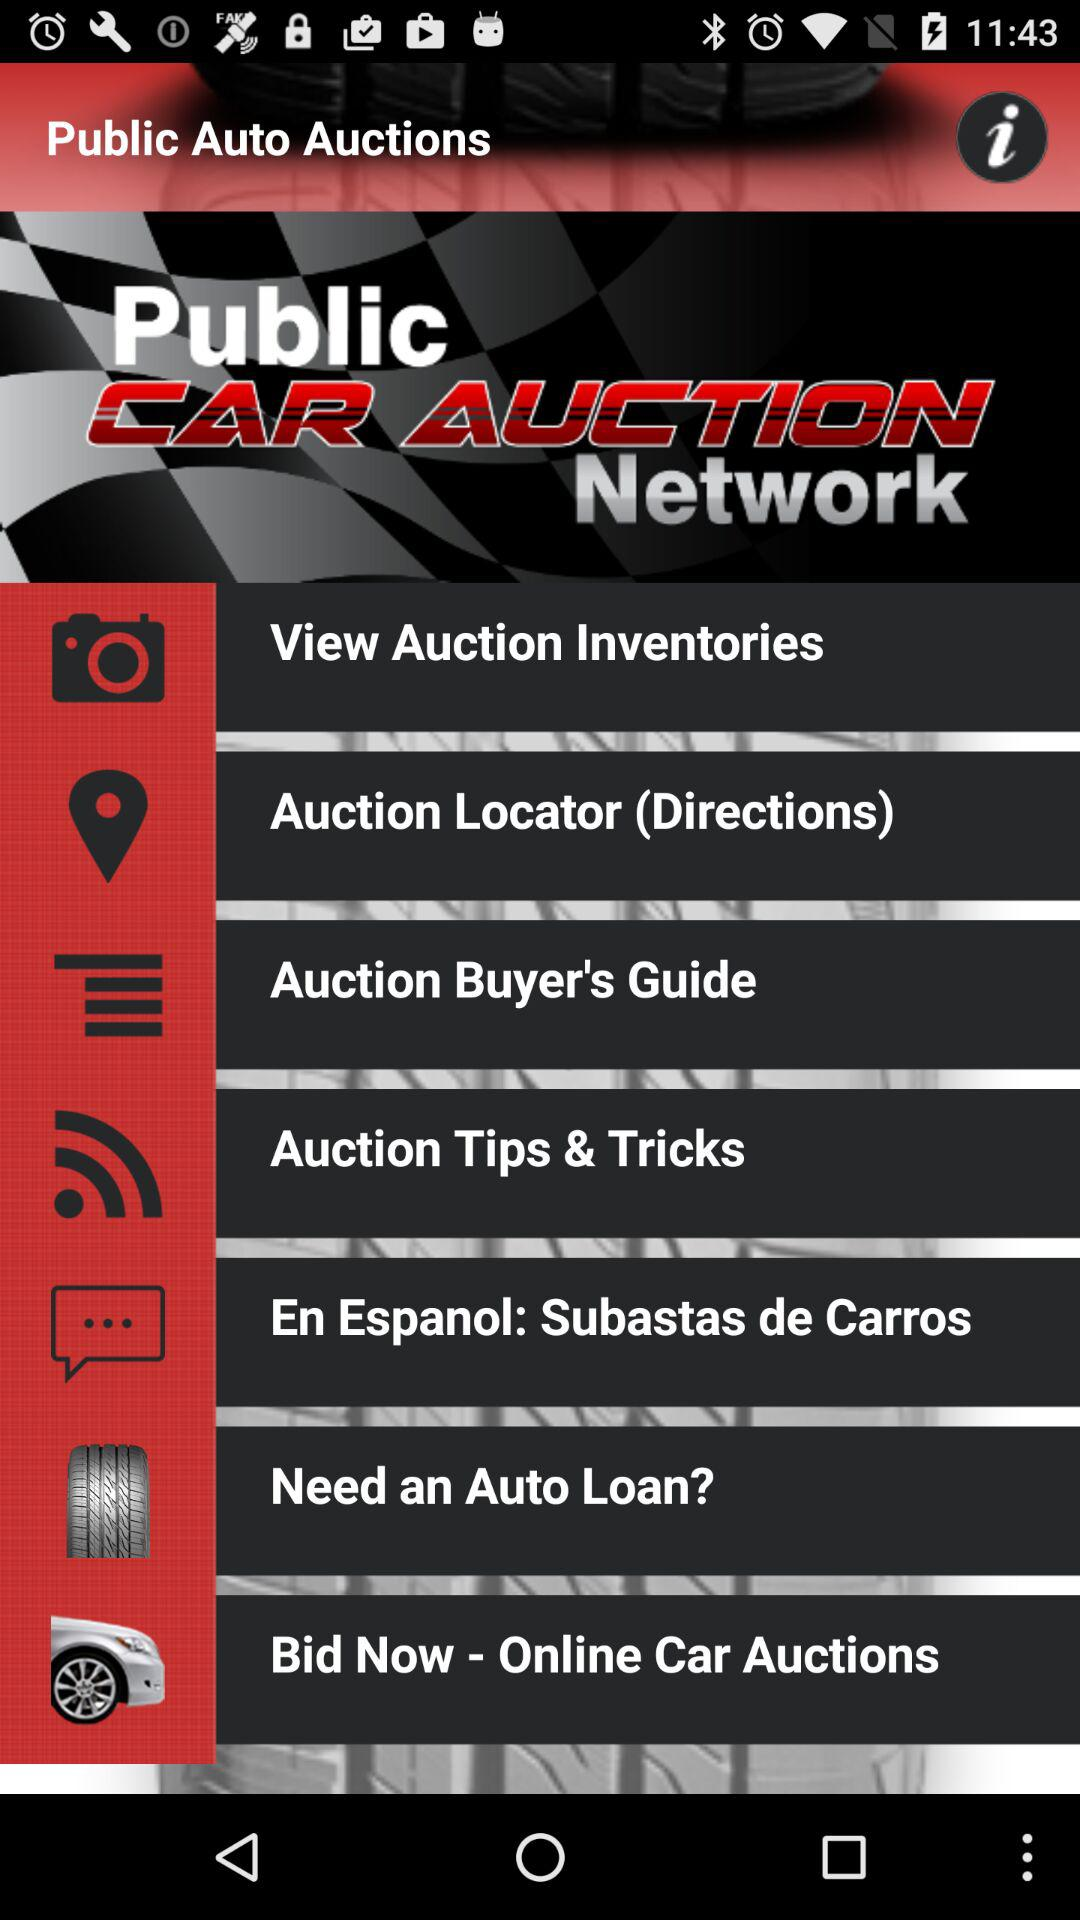What is the name of the application? The name of the application is "Public Auto Auctions". 